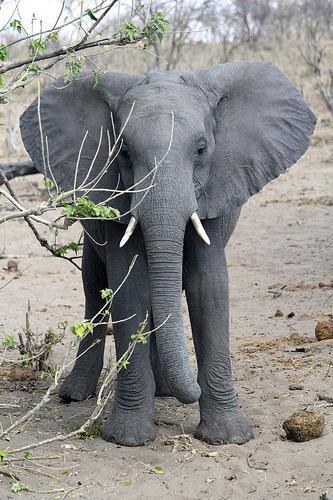How many horns does the elephant have?
Give a very brief answer. 2. 